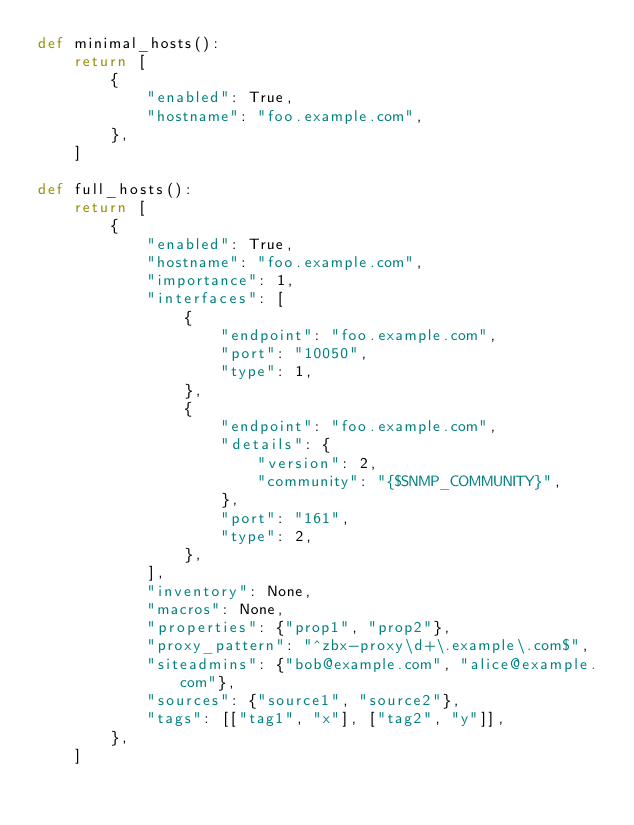Convert code to text. <code><loc_0><loc_0><loc_500><loc_500><_Python_>def minimal_hosts():
    return [
        {
            "enabled": True,
            "hostname": "foo.example.com",
        },
    ]

def full_hosts():
    return [
        {
            "enabled": True,
            "hostname": "foo.example.com",
            "importance": 1,
            "interfaces": [
                {
                    "endpoint": "foo.example.com",
                    "port": "10050",
                    "type": 1,
                },
                {
                    "endpoint": "foo.example.com",
                    "details": {
                        "version": 2,
                        "community": "{$SNMP_COMMUNITY}",
                    },
                    "port": "161",
                    "type": 2,
                },
            ],
            "inventory": None,
            "macros": None,
            "properties": {"prop1", "prop2"},
            "proxy_pattern": "^zbx-proxy\d+\.example\.com$",
            "siteadmins": {"bob@example.com", "alice@example.com"},
            "sources": {"source1", "source2"},
            "tags": [["tag1", "x"], ["tag2", "y"]],
        },
    ]
</code> 